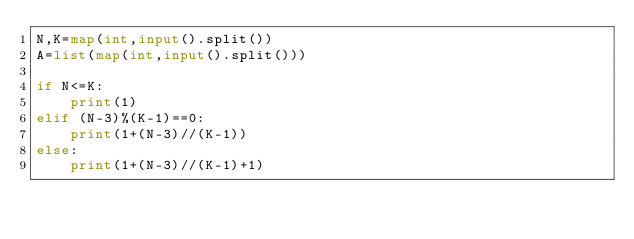<code> <loc_0><loc_0><loc_500><loc_500><_Python_>N,K=map(int,input().split())
A=list(map(int,input().split()))

if N<=K:
    print(1)
elif (N-3)%(K-1)==0:
    print(1+(N-3)//(K-1))
else:
    print(1+(N-3)//(K-1)+1)</code> 